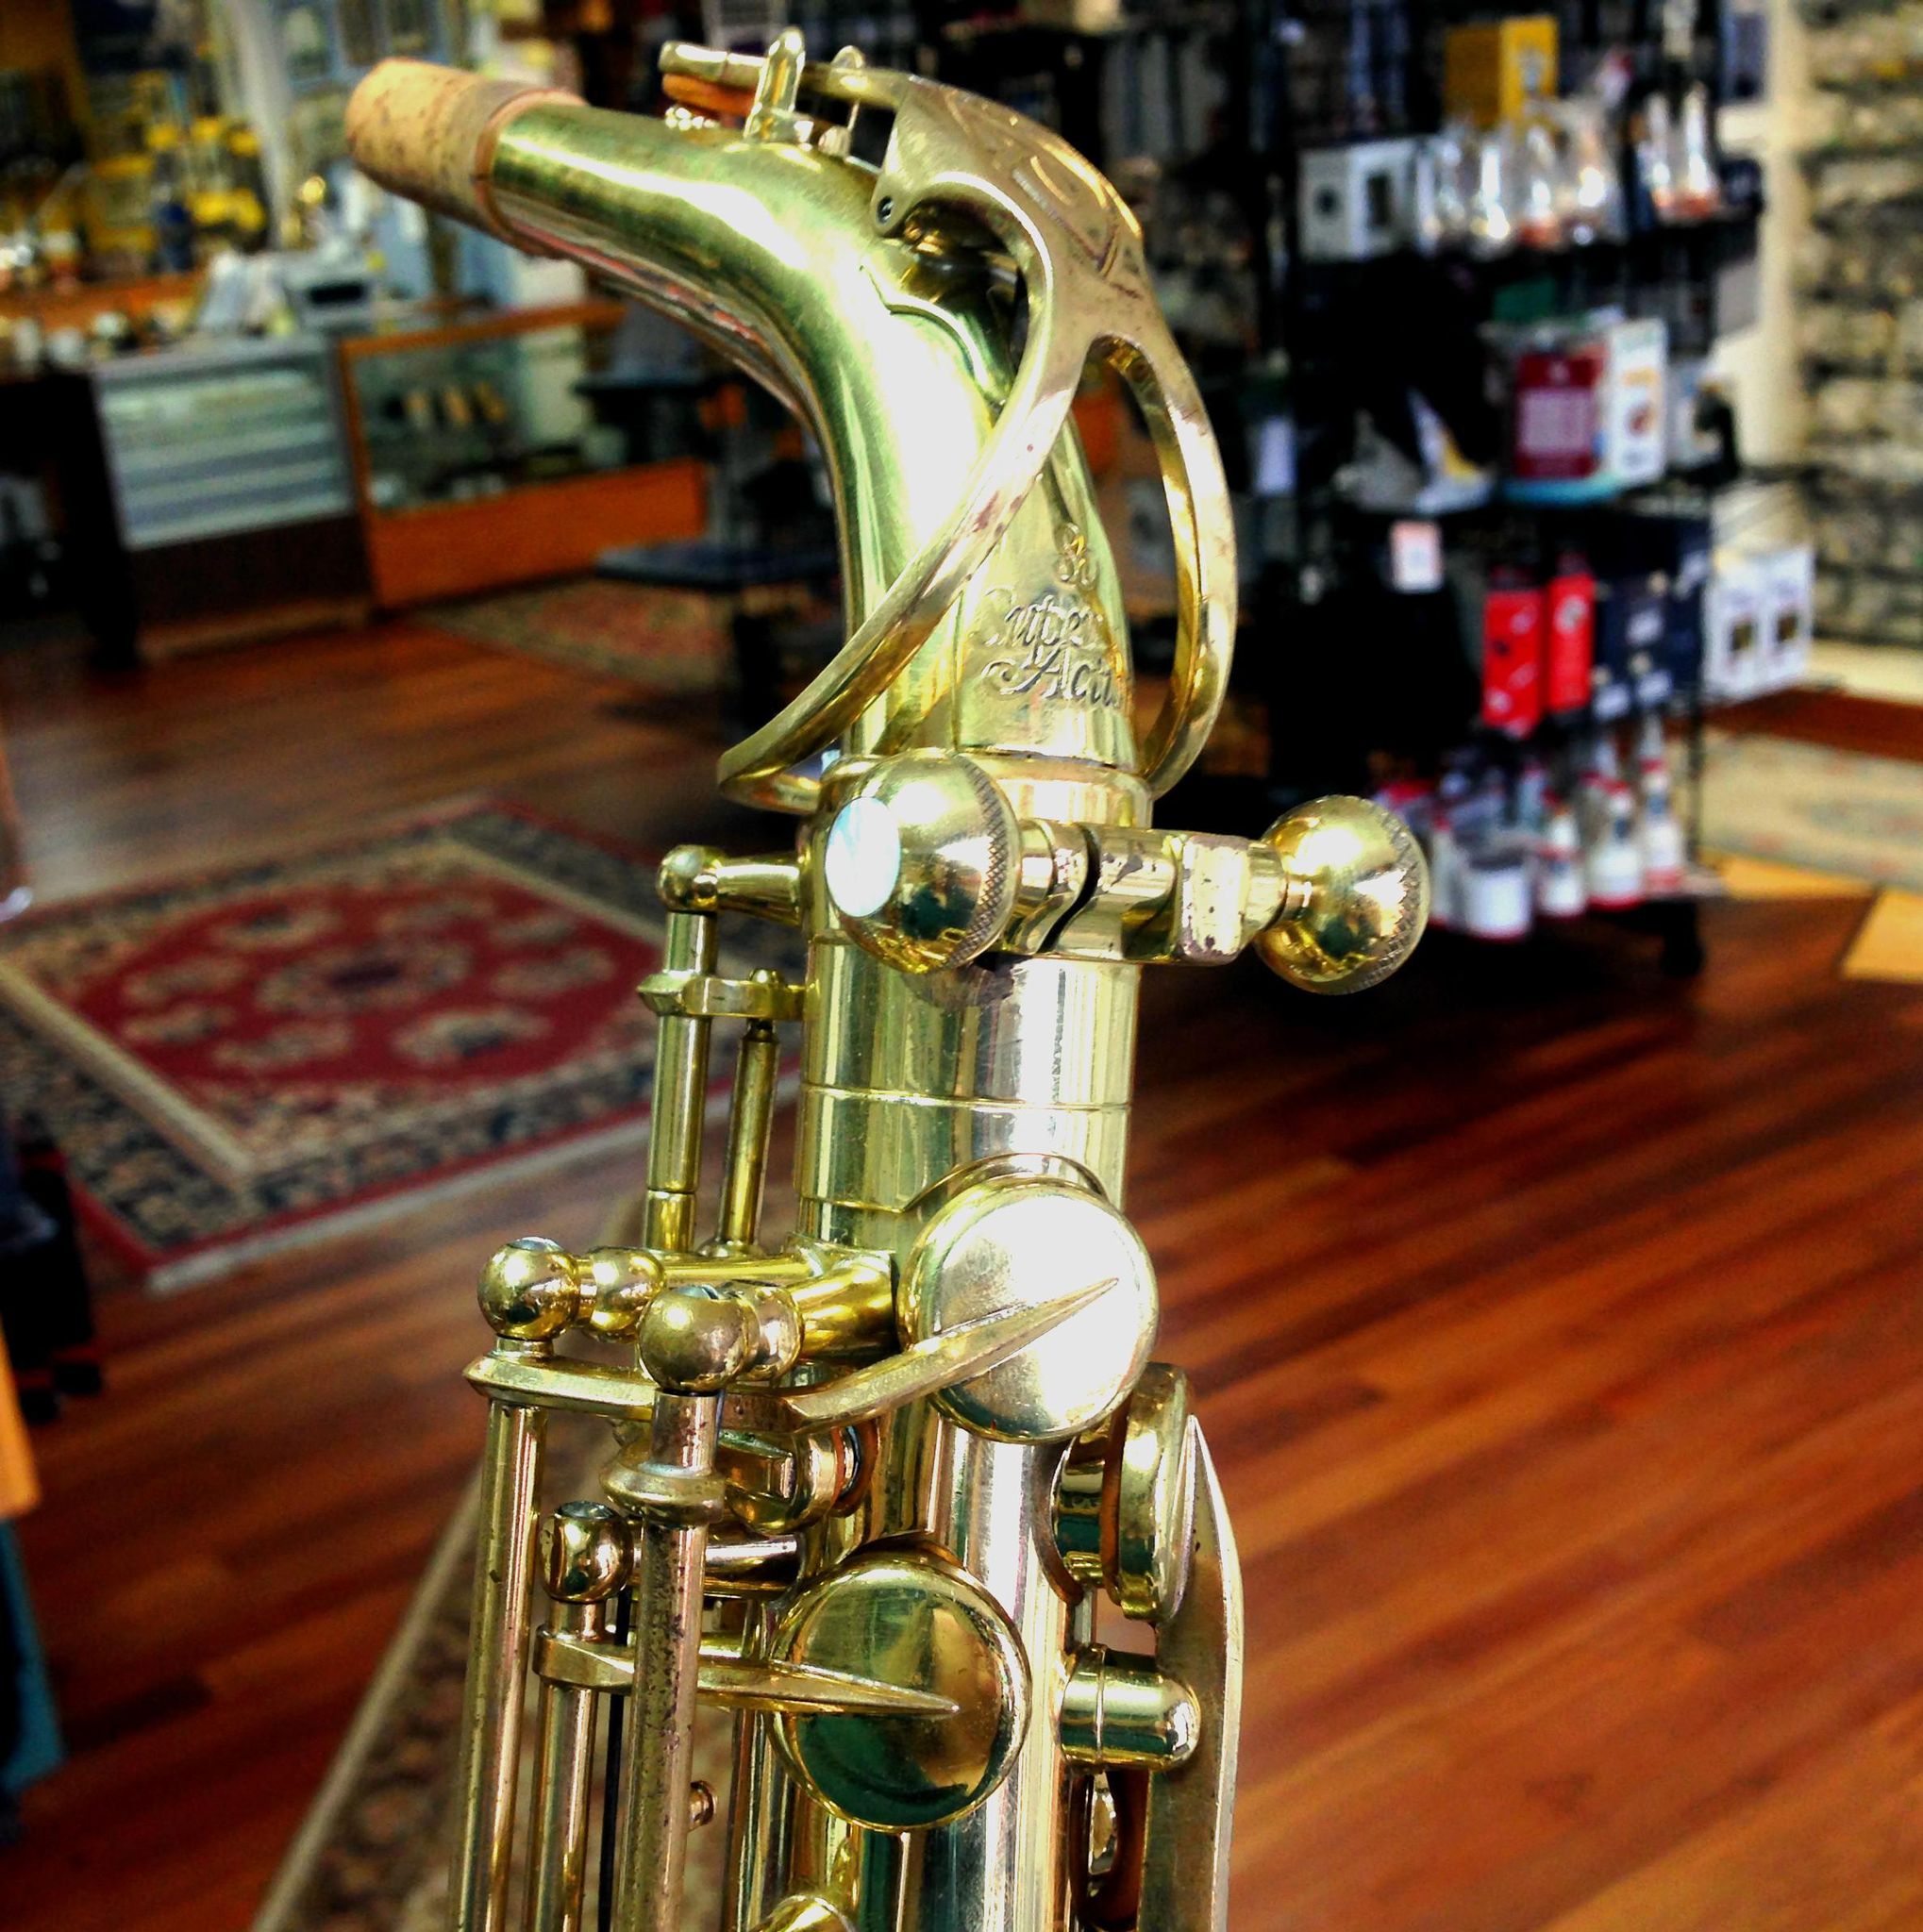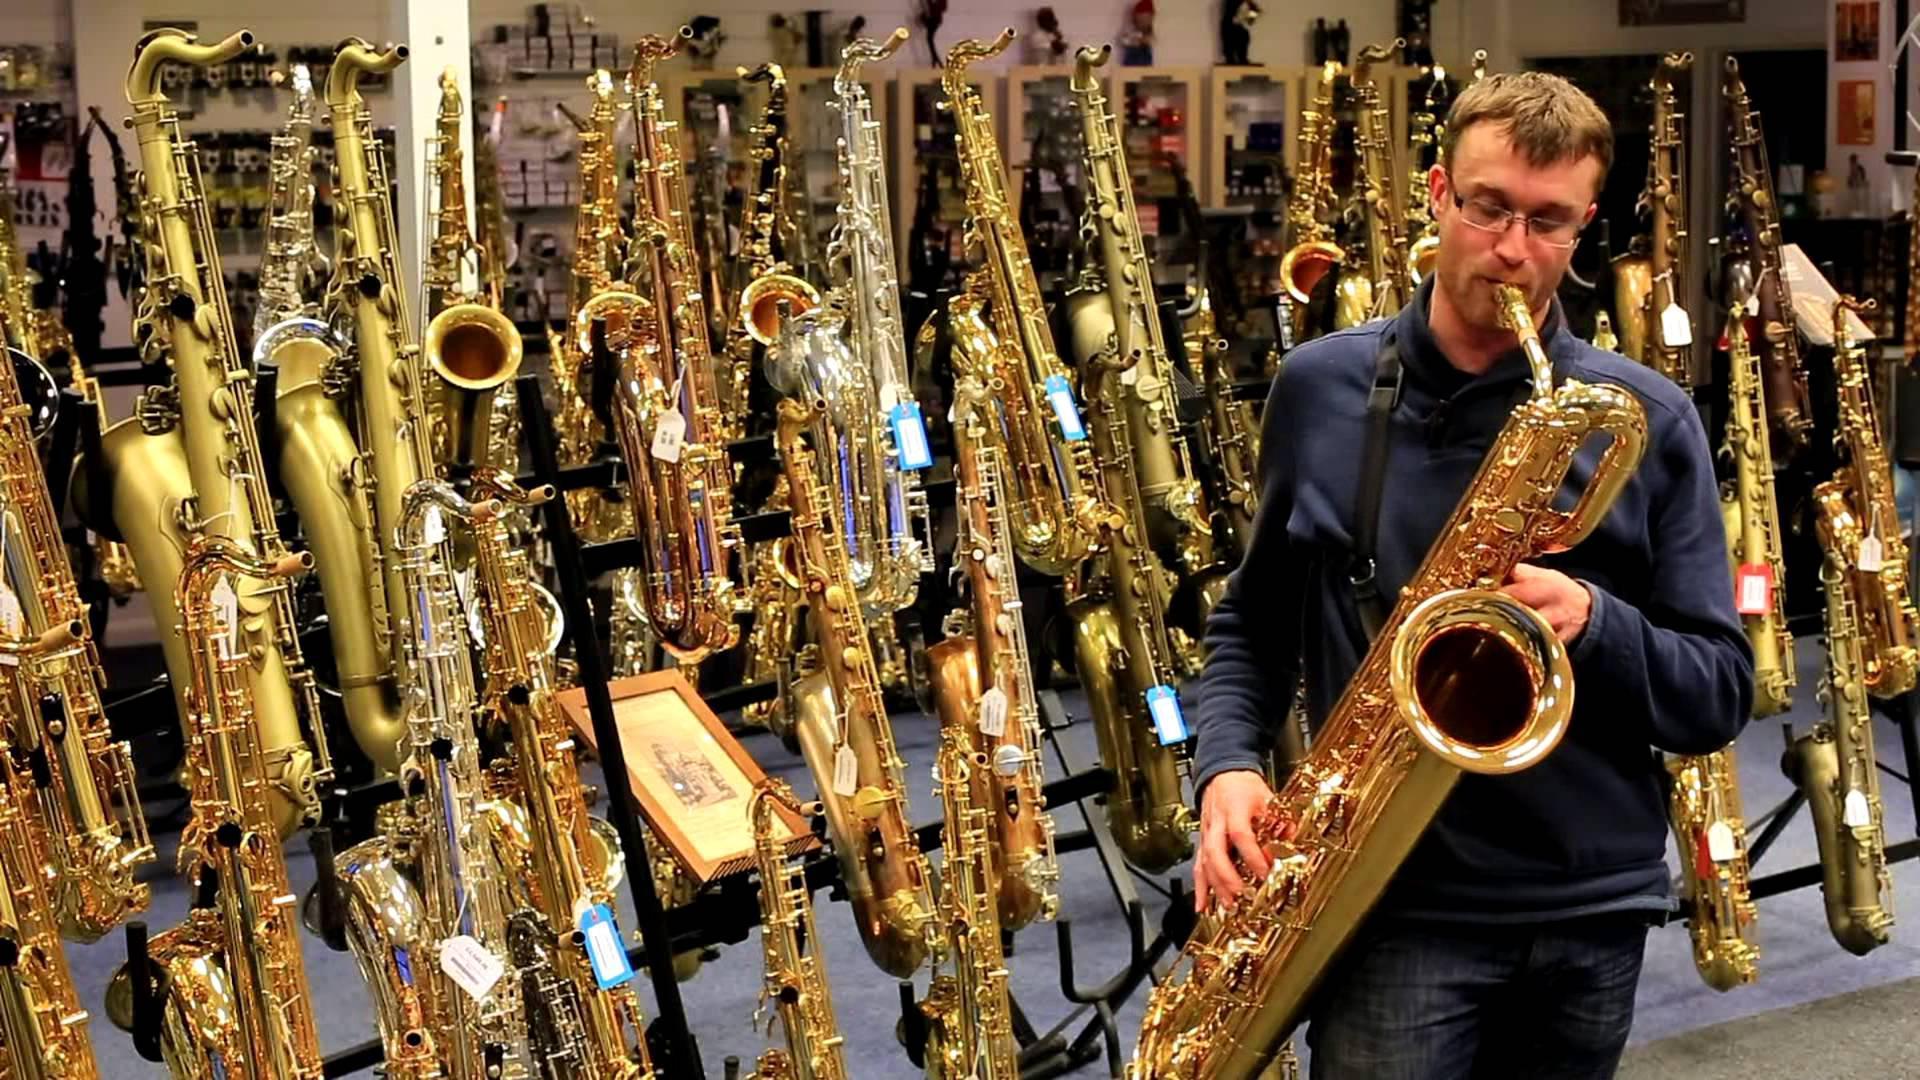The first image is the image on the left, the second image is the image on the right. Assess this claim about the two images: "Someone is playing a sax.". Correct or not? Answer yes or no. Yes. The first image is the image on the left, the second image is the image on the right. Analyze the images presented: Is the assertion "One image shows a man playing a saxophone and standing in front of a row of upright instruments." valid? Answer yes or no. Yes. 